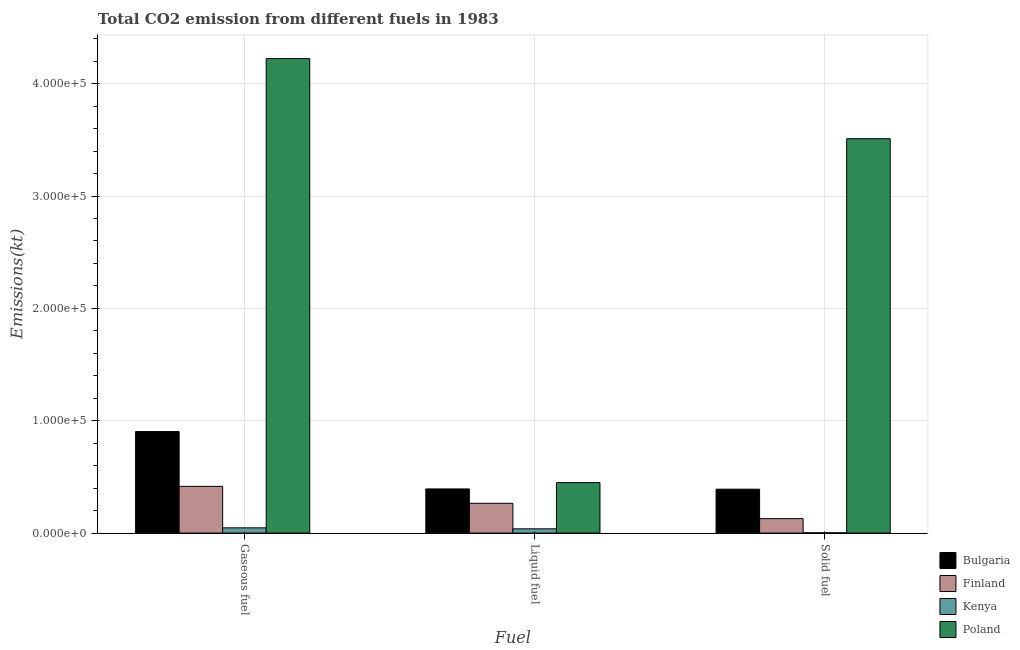How many groups of bars are there?
Make the answer very short. 3. Are the number of bars per tick equal to the number of legend labels?
Keep it short and to the point. Yes. How many bars are there on the 1st tick from the left?
Provide a short and direct response. 4. How many bars are there on the 2nd tick from the right?
Your response must be concise. 4. What is the label of the 2nd group of bars from the left?
Your answer should be very brief. Liquid fuel. What is the amount of co2 emissions from liquid fuel in Poland?
Ensure brevity in your answer.  4.49e+04. Across all countries, what is the maximum amount of co2 emissions from liquid fuel?
Offer a terse response. 4.49e+04. Across all countries, what is the minimum amount of co2 emissions from liquid fuel?
Provide a short and direct response. 3780.68. In which country was the amount of co2 emissions from gaseous fuel minimum?
Provide a succinct answer. Kenya. What is the total amount of co2 emissions from liquid fuel in the graph?
Offer a very short reply. 1.14e+05. What is the difference between the amount of co2 emissions from solid fuel in Finland and that in Bulgaria?
Offer a terse response. -2.62e+04. What is the difference between the amount of co2 emissions from solid fuel in Bulgaria and the amount of co2 emissions from gaseous fuel in Poland?
Offer a terse response. -3.83e+05. What is the average amount of co2 emissions from liquid fuel per country?
Your response must be concise. 2.86e+04. What is the difference between the amount of co2 emissions from gaseous fuel and amount of co2 emissions from solid fuel in Poland?
Make the answer very short. 7.13e+04. What is the ratio of the amount of co2 emissions from liquid fuel in Bulgaria to that in Finland?
Provide a short and direct response. 1.48. Is the amount of co2 emissions from liquid fuel in Finland less than that in Bulgaria?
Offer a very short reply. Yes. Is the difference between the amount of co2 emissions from liquid fuel in Finland and Kenya greater than the difference between the amount of co2 emissions from solid fuel in Finland and Kenya?
Your response must be concise. Yes. What is the difference between the highest and the second highest amount of co2 emissions from solid fuel?
Keep it short and to the point. 3.12e+05. What is the difference between the highest and the lowest amount of co2 emissions from gaseous fuel?
Keep it short and to the point. 4.18e+05. In how many countries, is the amount of co2 emissions from solid fuel greater than the average amount of co2 emissions from solid fuel taken over all countries?
Your answer should be compact. 1. What does the 2nd bar from the right in Liquid fuel represents?
Offer a very short reply. Kenya. Are the values on the major ticks of Y-axis written in scientific E-notation?
Offer a very short reply. Yes. Does the graph contain any zero values?
Make the answer very short. No. Does the graph contain grids?
Ensure brevity in your answer.  Yes. Where does the legend appear in the graph?
Your answer should be compact. Bottom right. What is the title of the graph?
Offer a very short reply. Total CO2 emission from different fuels in 1983. Does "Puerto Rico" appear as one of the legend labels in the graph?
Provide a short and direct response. No. What is the label or title of the X-axis?
Make the answer very short. Fuel. What is the label or title of the Y-axis?
Make the answer very short. Emissions(kt). What is the Emissions(kt) in Bulgaria in Gaseous fuel?
Ensure brevity in your answer.  9.04e+04. What is the Emissions(kt) of Finland in Gaseous fuel?
Provide a short and direct response. 4.16e+04. What is the Emissions(kt) of Kenya in Gaseous fuel?
Give a very brief answer. 4660.76. What is the Emissions(kt) of Poland in Gaseous fuel?
Keep it short and to the point. 4.22e+05. What is the Emissions(kt) of Bulgaria in Liquid fuel?
Offer a very short reply. 3.93e+04. What is the Emissions(kt) in Finland in Liquid fuel?
Your answer should be compact. 2.65e+04. What is the Emissions(kt) of Kenya in Liquid fuel?
Provide a succinct answer. 3780.68. What is the Emissions(kt) of Poland in Liquid fuel?
Your response must be concise. 4.49e+04. What is the Emissions(kt) of Bulgaria in Solid fuel?
Your answer should be very brief. 3.91e+04. What is the Emissions(kt) in Finland in Solid fuel?
Your answer should be compact. 1.28e+04. What is the Emissions(kt) in Kenya in Solid fuel?
Provide a short and direct response. 245.69. What is the Emissions(kt) in Poland in Solid fuel?
Ensure brevity in your answer.  3.51e+05. Across all Fuel, what is the maximum Emissions(kt) of Bulgaria?
Your answer should be very brief. 9.04e+04. Across all Fuel, what is the maximum Emissions(kt) in Finland?
Make the answer very short. 4.16e+04. Across all Fuel, what is the maximum Emissions(kt) in Kenya?
Ensure brevity in your answer.  4660.76. Across all Fuel, what is the maximum Emissions(kt) in Poland?
Your answer should be very brief. 4.22e+05. Across all Fuel, what is the minimum Emissions(kt) in Bulgaria?
Your response must be concise. 3.91e+04. Across all Fuel, what is the minimum Emissions(kt) of Finland?
Offer a terse response. 1.28e+04. Across all Fuel, what is the minimum Emissions(kt) of Kenya?
Make the answer very short. 245.69. Across all Fuel, what is the minimum Emissions(kt) of Poland?
Offer a terse response. 4.49e+04. What is the total Emissions(kt) in Bulgaria in the graph?
Offer a very short reply. 1.69e+05. What is the total Emissions(kt) of Finland in the graph?
Your answer should be compact. 8.09e+04. What is the total Emissions(kt) in Kenya in the graph?
Offer a very short reply. 8687.12. What is the total Emissions(kt) in Poland in the graph?
Provide a short and direct response. 8.18e+05. What is the difference between the Emissions(kt) of Bulgaria in Gaseous fuel and that in Liquid fuel?
Your answer should be compact. 5.11e+04. What is the difference between the Emissions(kt) in Finland in Gaseous fuel and that in Liquid fuel?
Offer a very short reply. 1.51e+04. What is the difference between the Emissions(kt) in Kenya in Gaseous fuel and that in Liquid fuel?
Ensure brevity in your answer.  880.08. What is the difference between the Emissions(kt) of Poland in Gaseous fuel and that in Liquid fuel?
Your answer should be very brief. 3.77e+05. What is the difference between the Emissions(kt) of Bulgaria in Gaseous fuel and that in Solid fuel?
Make the answer very short. 5.13e+04. What is the difference between the Emissions(kt) of Finland in Gaseous fuel and that in Solid fuel?
Provide a succinct answer. 2.87e+04. What is the difference between the Emissions(kt) in Kenya in Gaseous fuel and that in Solid fuel?
Offer a terse response. 4415.07. What is the difference between the Emissions(kt) of Poland in Gaseous fuel and that in Solid fuel?
Offer a terse response. 7.13e+04. What is the difference between the Emissions(kt) of Bulgaria in Liquid fuel and that in Solid fuel?
Offer a very short reply. 223.69. What is the difference between the Emissions(kt) of Finland in Liquid fuel and that in Solid fuel?
Ensure brevity in your answer.  1.37e+04. What is the difference between the Emissions(kt) of Kenya in Liquid fuel and that in Solid fuel?
Your answer should be very brief. 3534.99. What is the difference between the Emissions(kt) of Poland in Liquid fuel and that in Solid fuel?
Your answer should be compact. -3.06e+05. What is the difference between the Emissions(kt) in Bulgaria in Gaseous fuel and the Emissions(kt) in Finland in Liquid fuel?
Your answer should be very brief. 6.39e+04. What is the difference between the Emissions(kt) of Bulgaria in Gaseous fuel and the Emissions(kt) of Kenya in Liquid fuel?
Provide a succinct answer. 8.66e+04. What is the difference between the Emissions(kt) in Bulgaria in Gaseous fuel and the Emissions(kt) in Poland in Liquid fuel?
Offer a terse response. 4.55e+04. What is the difference between the Emissions(kt) of Finland in Gaseous fuel and the Emissions(kt) of Kenya in Liquid fuel?
Provide a succinct answer. 3.78e+04. What is the difference between the Emissions(kt) in Finland in Gaseous fuel and the Emissions(kt) in Poland in Liquid fuel?
Your response must be concise. -3329.64. What is the difference between the Emissions(kt) of Kenya in Gaseous fuel and the Emissions(kt) of Poland in Liquid fuel?
Make the answer very short. -4.02e+04. What is the difference between the Emissions(kt) in Bulgaria in Gaseous fuel and the Emissions(kt) in Finland in Solid fuel?
Make the answer very short. 7.75e+04. What is the difference between the Emissions(kt) of Bulgaria in Gaseous fuel and the Emissions(kt) of Kenya in Solid fuel?
Give a very brief answer. 9.01e+04. What is the difference between the Emissions(kt) in Bulgaria in Gaseous fuel and the Emissions(kt) in Poland in Solid fuel?
Your answer should be compact. -2.61e+05. What is the difference between the Emissions(kt) in Finland in Gaseous fuel and the Emissions(kt) in Kenya in Solid fuel?
Your answer should be very brief. 4.13e+04. What is the difference between the Emissions(kt) of Finland in Gaseous fuel and the Emissions(kt) of Poland in Solid fuel?
Offer a terse response. -3.09e+05. What is the difference between the Emissions(kt) in Kenya in Gaseous fuel and the Emissions(kt) in Poland in Solid fuel?
Make the answer very short. -3.46e+05. What is the difference between the Emissions(kt) in Bulgaria in Liquid fuel and the Emissions(kt) in Finland in Solid fuel?
Provide a short and direct response. 2.64e+04. What is the difference between the Emissions(kt) of Bulgaria in Liquid fuel and the Emissions(kt) of Kenya in Solid fuel?
Offer a terse response. 3.90e+04. What is the difference between the Emissions(kt) of Bulgaria in Liquid fuel and the Emissions(kt) of Poland in Solid fuel?
Provide a succinct answer. -3.12e+05. What is the difference between the Emissions(kt) in Finland in Liquid fuel and the Emissions(kt) in Kenya in Solid fuel?
Give a very brief answer. 2.63e+04. What is the difference between the Emissions(kt) in Finland in Liquid fuel and the Emissions(kt) in Poland in Solid fuel?
Ensure brevity in your answer.  -3.25e+05. What is the difference between the Emissions(kt) of Kenya in Liquid fuel and the Emissions(kt) of Poland in Solid fuel?
Your answer should be compact. -3.47e+05. What is the average Emissions(kt) of Bulgaria per Fuel?
Give a very brief answer. 5.62e+04. What is the average Emissions(kt) in Finland per Fuel?
Offer a very short reply. 2.70e+04. What is the average Emissions(kt) of Kenya per Fuel?
Offer a very short reply. 2895.71. What is the average Emissions(kt) in Poland per Fuel?
Your answer should be compact. 2.73e+05. What is the difference between the Emissions(kt) of Bulgaria and Emissions(kt) of Finland in Gaseous fuel?
Your answer should be very brief. 4.88e+04. What is the difference between the Emissions(kt) of Bulgaria and Emissions(kt) of Kenya in Gaseous fuel?
Make the answer very short. 8.57e+04. What is the difference between the Emissions(kt) of Bulgaria and Emissions(kt) of Poland in Gaseous fuel?
Make the answer very short. -3.32e+05. What is the difference between the Emissions(kt) of Finland and Emissions(kt) of Kenya in Gaseous fuel?
Provide a succinct answer. 3.69e+04. What is the difference between the Emissions(kt) of Finland and Emissions(kt) of Poland in Gaseous fuel?
Offer a very short reply. -3.81e+05. What is the difference between the Emissions(kt) in Kenya and Emissions(kt) in Poland in Gaseous fuel?
Give a very brief answer. -4.18e+05. What is the difference between the Emissions(kt) of Bulgaria and Emissions(kt) of Finland in Liquid fuel?
Provide a short and direct response. 1.28e+04. What is the difference between the Emissions(kt) of Bulgaria and Emissions(kt) of Kenya in Liquid fuel?
Your response must be concise. 3.55e+04. What is the difference between the Emissions(kt) of Bulgaria and Emissions(kt) of Poland in Liquid fuel?
Your response must be concise. -5621.51. What is the difference between the Emissions(kt) of Finland and Emissions(kt) of Kenya in Liquid fuel?
Ensure brevity in your answer.  2.27e+04. What is the difference between the Emissions(kt) of Finland and Emissions(kt) of Poland in Liquid fuel?
Give a very brief answer. -1.84e+04. What is the difference between the Emissions(kt) in Kenya and Emissions(kt) in Poland in Liquid fuel?
Your response must be concise. -4.11e+04. What is the difference between the Emissions(kt) of Bulgaria and Emissions(kt) of Finland in Solid fuel?
Your answer should be very brief. 2.62e+04. What is the difference between the Emissions(kt) of Bulgaria and Emissions(kt) of Kenya in Solid fuel?
Ensure brevity in your answer.  3.88e+04. What is the difference between the Emissions(kt) of Bulgaria and Emissions(kt) of Poland in Solid fuel?
Provide a short and direct response. -3.12e+05. What is the difference between the Emissions(kt) of Finland and Emissions(kt) of Kenya in Solid fuel?
Your answer should be compact. 1.26e+04. What is the difference between the Emissions(kt) of Finland and Emissions(kt) of Poland in Solid fuel?
Make the answer very short. -3.38e+05. What is the difference between the Emissions(kt) of Kenya and Emissions(kt) of Poland in Solid fuel?
Your response must be concise. -3.51e+05. What is the ratio of the Emissions(kt) in Bulgaria in Gaseous fuel to that in Liquid fuel?
Provide a short and direct response. 2.3. What is the ratio of the Emissions(kt) in Finland in Gaseous fuel to that in Liquid fuel?
Make the answer very short. 1.57. What is the ratio of the Emissions(kt) in Kenya in Gaseous fuel to that in Liquid fuel?
Your response must be concise. 1.23. What is the ratio of the Emissions(kt) of Poland in Gaseous fuel to that in Liquid fuel?
Provide a succinct answer. 9.4. What is the ratio of the Emissions(kt) in Bulgaria in Gaseous fuel to that in Solid fuel?
Ensure brevity in your answer.  2.31. What is the ratio of the Emissions(kt) in Finland in Gaseous fuel to that in Solid fuel?
Your answer should be compact. 3.24. What is the ratio of the Emissions(kt) in Kenya in Gaseous fuel to that in Solid fuel?
Ensure brevity in your answer.  18.97. What is the ratio of the Emissions(kt) in Poland in Gaseous fuel to that in Solid fuel?
Offer a terse response. 1.2. What is the ratio of the Emissions(kt) in Bulgaria in Liquid fuel to that in Solid fuel?
Give a very brief answer. 1.01. What is the ratio of the Emissions(kt) of Finland in Liquid fuel to that in Solid fuel?
Make the answer very short. 2.06. What is the ratio of the Emissions(kt) of Kenya in Liquid fuel to that in Solid fuel?
Your answer should be compact. 15.39. What is the ratio of the Emissions(kt) in Poland in Liquid fuel to that in Solid fuel?
Your response must be concise. 0.13. What is the difference between the highest and the second highest Emissions(kt) in Bulgaria?
Provide a succinct answer. 5.11e+04. What is the difference between the highest and the second highest Emissions(kt) of Finland?
Your response must be concise. 1.51e+04. What is the difference between the highest and the second highest Emissions(kt) in Kenya?
Give a very brief answer. 880.08. What is the difference between the highest and the second highest Emissions(kt) of Poland?
Keep it short and to the point. 7.13e+04. What is the difference between the highest and the lowest Emissions(kt) in Bulgaria?
Your answer should be very brief. 5.13e+04. What is the difference between the highest and the lowest Emissions(kt) of Finland?
Provide a short and direct response. 2.87e+04. What is the difference between the highest and the lowest Emissions(kt) in Kenya?
Your answer should be compact. 4415.07. What is the difference between the highest and the lowest Emissions(kt) of Poland?
Offer a terse response. 3.77e+05. 